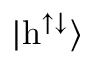Convert formula to latex. <formula><loc_0><loc_0><loc_500><loc_500>| h ^ { \uparrow \downarrow } \rangle</formula> 